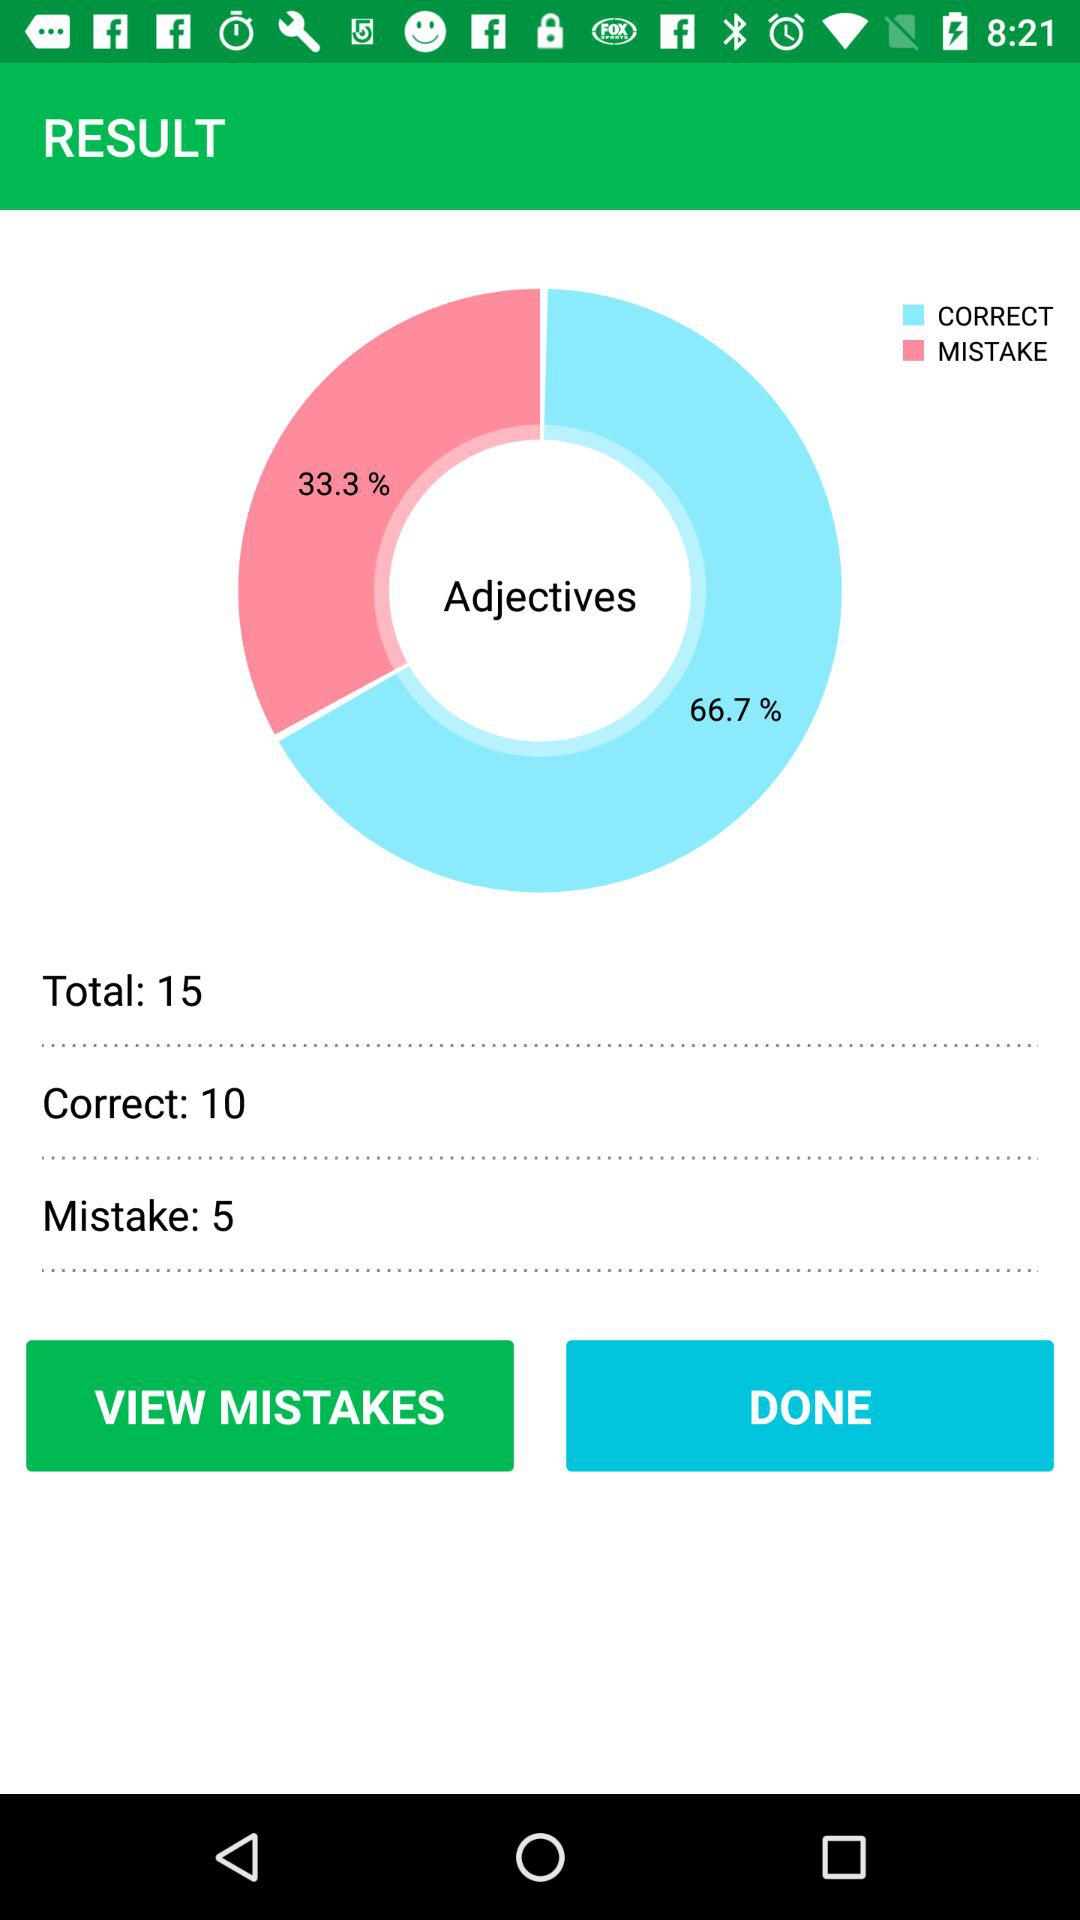What is the number of mistakes in "Adjectives"? The number of mistakes in "Adjectives" is 5. 